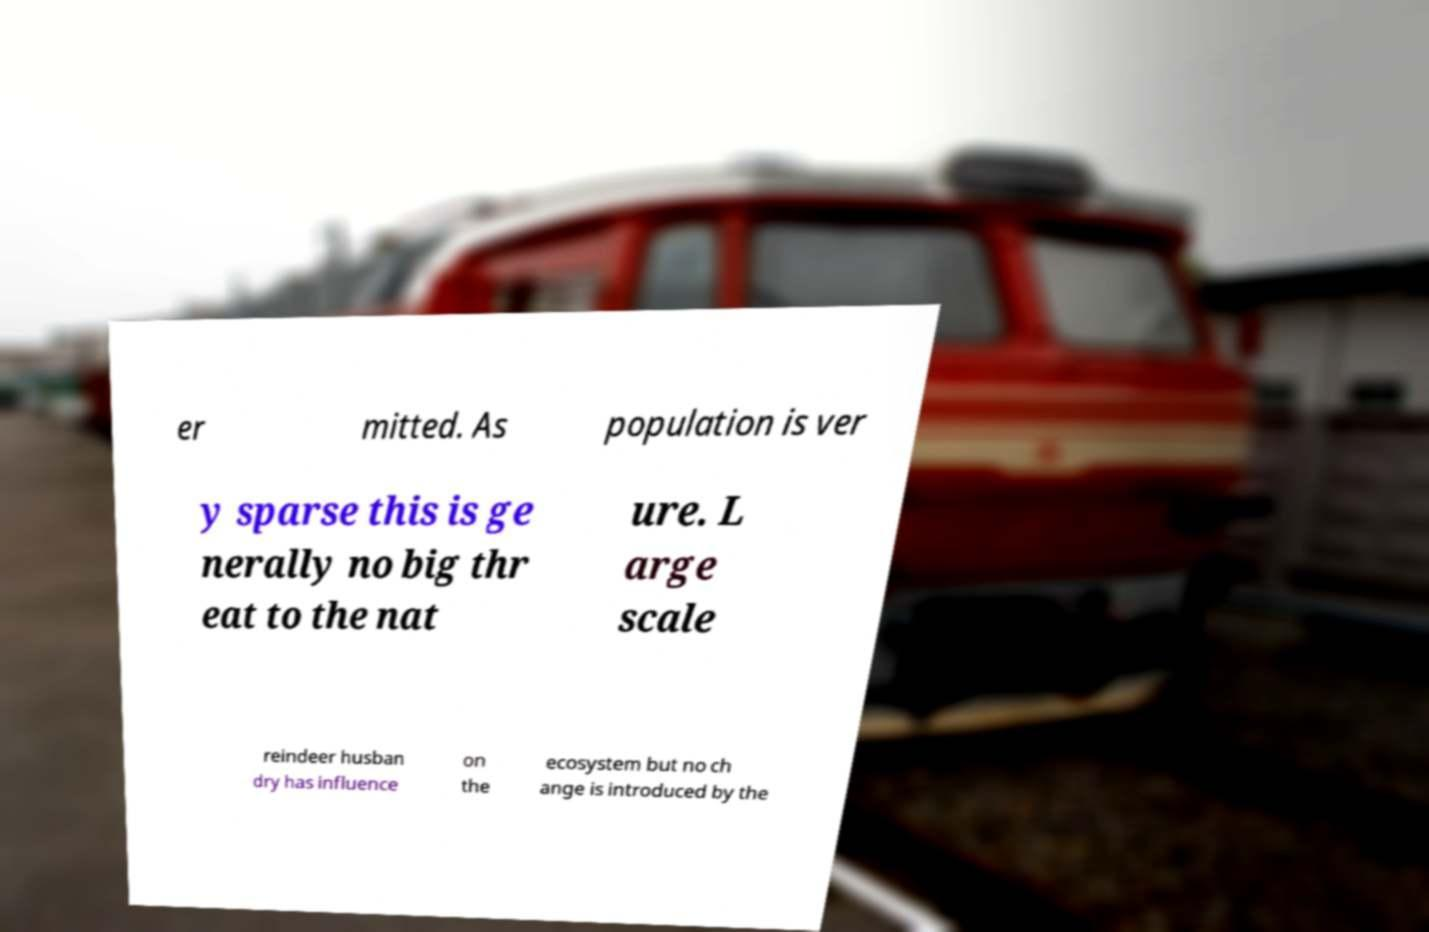For documentation purposes, I need the text within this image transcribed. Could you provide that? er mitted. As population is ver y sparse this is ge nerally no big thr eat to the nat ure. L arge scale reindeer husban dry has influence on the ecosystem but no ch ange is introduced by the 